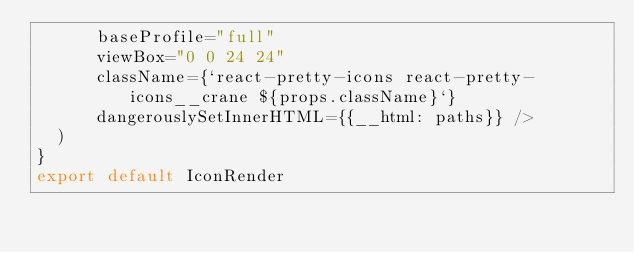<code> <loc_0><loc_0><loc_500><loc_500><_JavaScript_>      baseProfile="full"
      viewBox="0 0 24 24"
      className={`react-pretty-icons react-pretty-icons__crane ${props.className}`}
      dangerouslySetInnerHTML={{__html: paths}} />
  )
}
export default IconRender</code> 